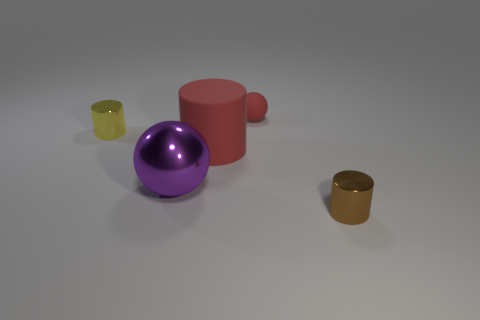Subtract all large rubber cylinders. How many cylinders are left? 2 Add 5 large purple matte blocks. How many objects exist? 10 Subtract all red cylinders. How many cylinders are left? 2 Subtract 2 cylinders. How many cylinders are left? 1 Subtract 0 cyan blocks. How many objects are left? 5 Subtract all cylinders. How many objects are left? 2 Subtract all yellow cylinders. Subtract all gray spheres. How many cylinders are left? 2 Subtract all big red objects. Subtract all metal balls. How many objects are left? 3 Add 4 big red rubber things. How many big red rubber things are left? 5 Add 4 big metallic cubes. How many big metallic cubes exist? 4 